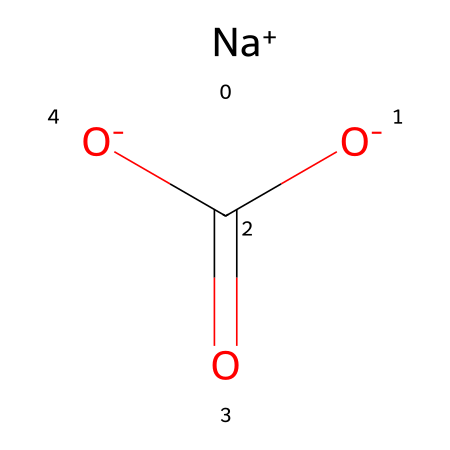What is the name of this chemical? The chemical structure provided corresponds to sodium bicarbonate, which is commonly known as baking soda. The presence of sodium (Na) and the bicarbonate ion (HCO3) in the structure confirms its identity.
Answer: sodium bicarbonate How many sodium atoms are in the structure? By examining the SMILES notation, there is one [Na+] that represents a single sodium atom in the compound.
Answer: one Which elements are present in sodium bicarbonate? The SMILES representation shows [Na+], [O-], and the carbonyl group C(=O) along with O, indicating the presence of sodium, oxygen, carbon, and hydrogen (from the implied hydrogen in the bicarbonate ion).
Answer: sodium, oxygen, carbon, hydrogen How many oxygen atoms does sodium bicarbonate contain? The SMILES representation includes two -O and one (=O), totaling three oxygen atoms in the whole structure.
Answer: three What type of chemical compound is sodium bicarbonate? Sodium bicarbonate is classified as a weak base due to the presence of the bicarbonate ion, which can both donate and accept protons in solution, leading to a buffering action.
Answer: weak base What is the charge of the bicarbonate ion in this structure? The bicarbonate ion (HCO3) generally carries a charge of -1, which is indicated by the two [O-] in the SMILES notation and the absence of any additional positive charges surrounding it.
Answer: minus one 